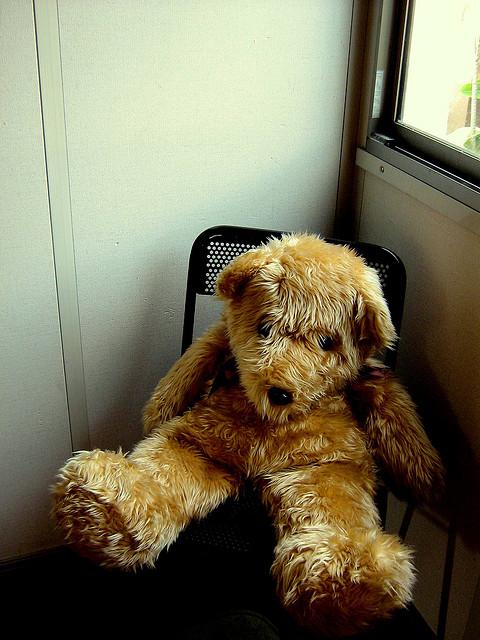What is sitting in the chair?
Short answer required. Teddy bear. Is the sun shining through the window?
Give a very brief answer. Yes. Can this toy walk?
Be succinct. No. 